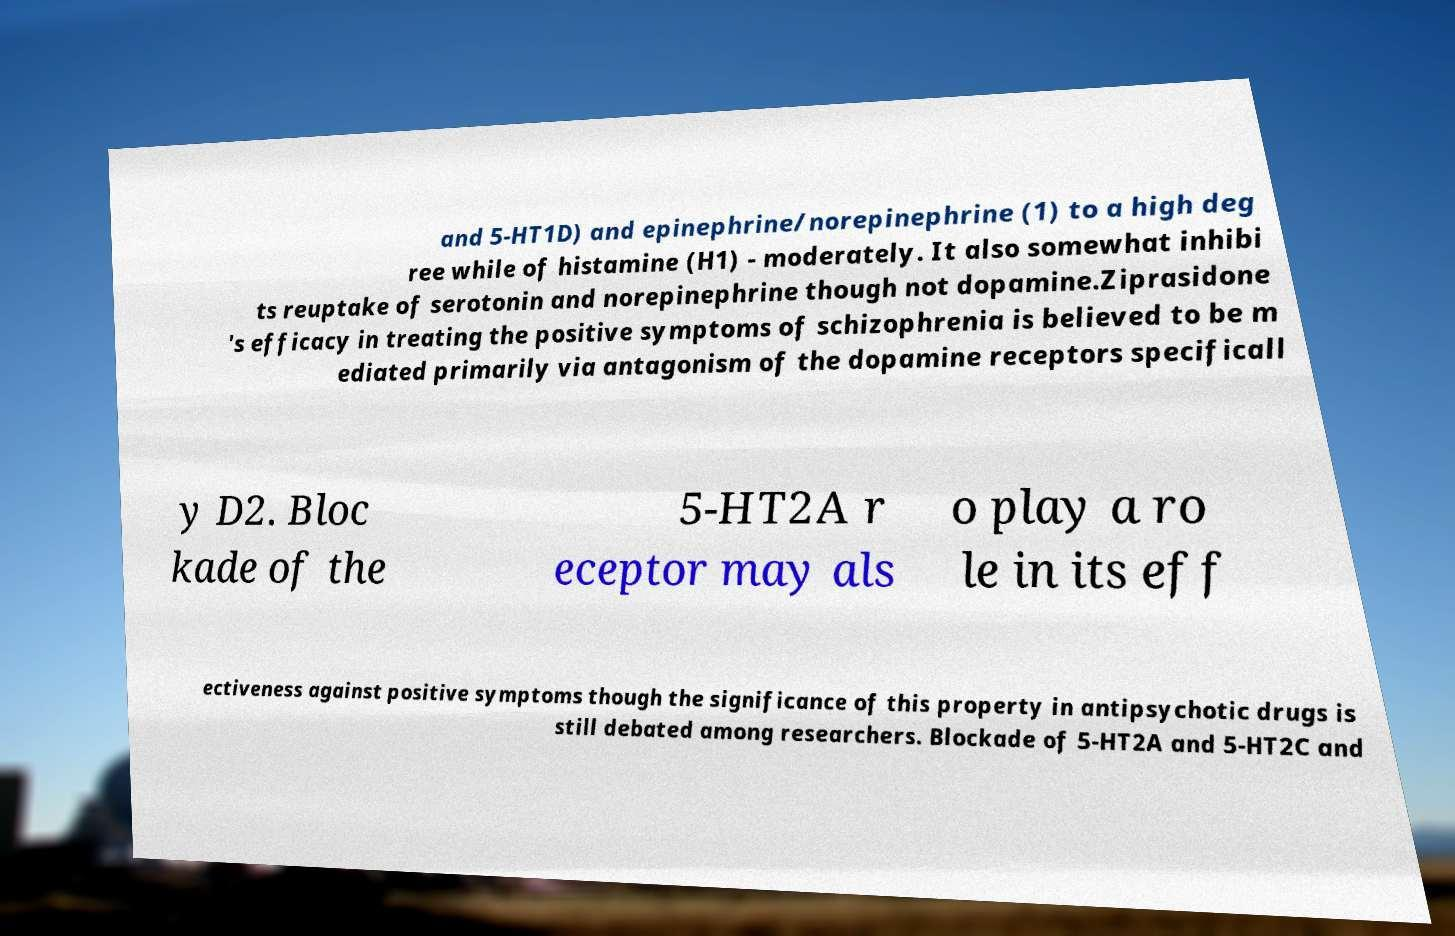What messages or text are displayed in this image? I need them in a readable, typed format. and 5-HT1D) and epinephrine/norepinephrine (1) to a high deg ree while of histamine (H1) - moderately. It also somewhat inhibi ts reuptake of serotonin and norepinephrine though not dopamine.Ziprasidone 's efficacy in treating the positive symptoms of schizophrenia is believed to be m ediated primarily via antagonism of the dopamine receptors specificall y D2. Bloc kade of the 5-HT2A r eceptor may als o play a ro le in its eff ectiveness against positive symptoms though the significance of this property in antipsychotic drugs is still debated among researchers. Blockade of 5-HT2A and 5-HT2C and 